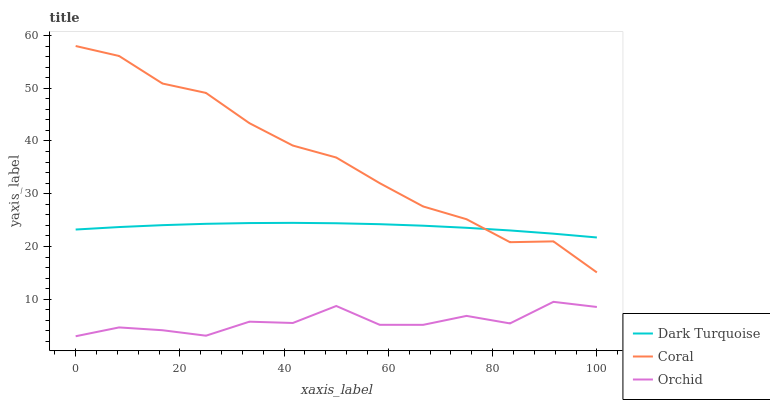Does Orchid have the minimum area under the curve?
Answer yes or no. Yes. Does Coral have the maximum area under the curve?
Answer yes or no. Yes. Does Coral have the minimum area under the curve?
Answer yes or no. No. Does Orchid have the maximum area under the curve?
Answer yes or no. No. Is Dark Turquoise the smoothest?
Answer yes or no. Yes. Is Orchid the roughest?
Answer yes or no. Yes. Is Coral the smoothest?
Answer yes or no. No. Is Coral the roughest?
Answer yes or no. No. Does Coral have the lowest value?
Answer yes or no. No. Does Coral have the highest value?
Answer yes or no. Yes. Does Orchid have the highest value?
Answer yes or no. No. Is Orchid less than Coral?
Answer yes or no. Yes. Is Coral greater than Orchid?
Answer yes or no. Yes. Does Coral intersect Dark Turquoise?
Answer yes or no. Yes. Is Coral less than Dark Turquoise?
Answer yes or no. No. Is Coral greater than Dark Turquoise?
Answer yes or no. No. Does Orchid intersect Coral?
Answer yes or no. No. 